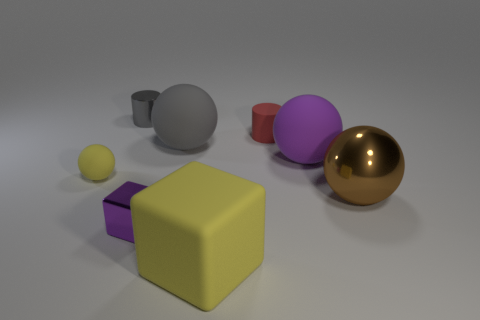Subtract all purple cylinders. Subtract all brown balls. How many cylinders are left? 2 Add 1 metallic balls. How many objects exist? 9 Subtract all cubes. How many objects are left? 6 Add 7 tiny cylinders. How many tiny cylinders exist? 9 Subtract 1 red cylinders. How many objects are left? 7 Subtract all brown balls. Subtract all large yellow rubber cubes. How many objects are left? 6 Add 5 large yellow rubber cubes. How many large yellow rubber cubes are left? 6 